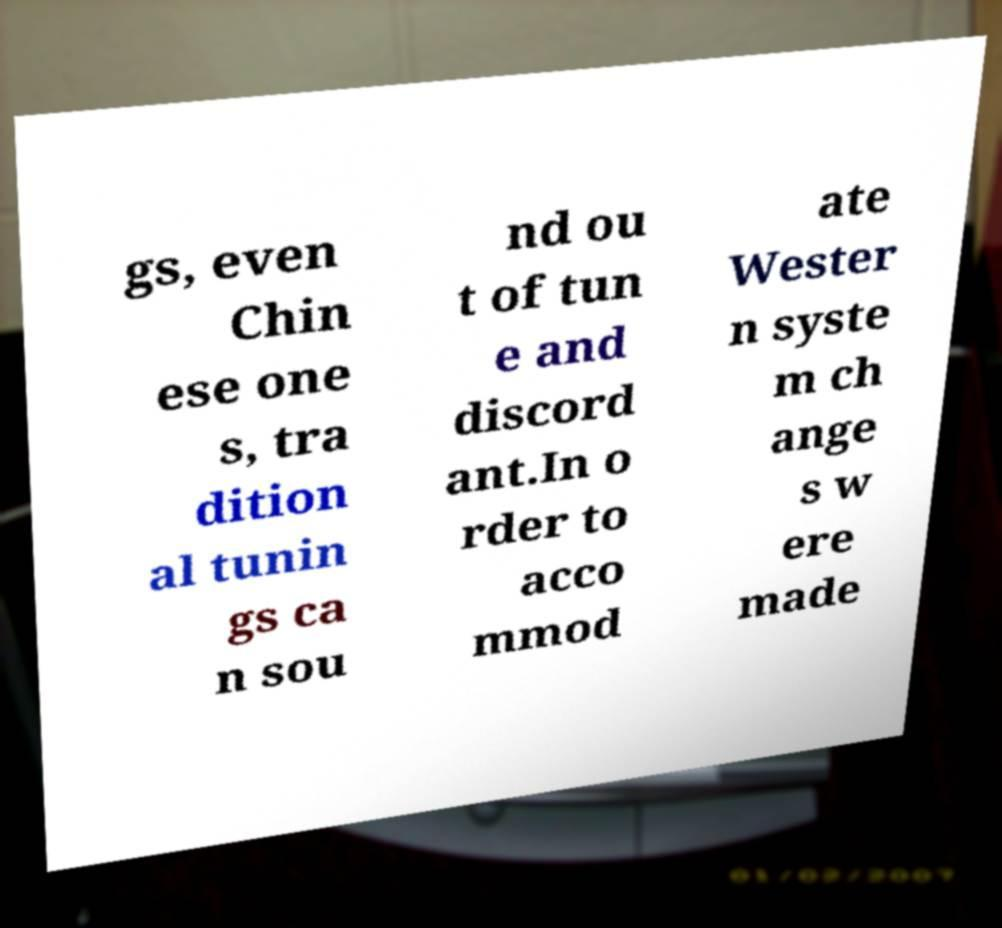Please identify and transcribe the text found in this image. gs, even Chin ese one s, tra dition al tunin gs ca n sou nd ou t of tun e and discord ant.In o rder to acco mmod ate Wester n syste m ch ange s w ere made 